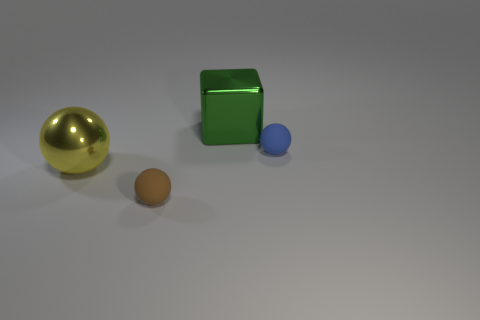Do the yellow shiny object and the brown object have the same shape?
Provide a short and direct response. Yes. How many things are both behind the small brown sphere and on the right side of the yellow shiny ball?
Make the answer very short. 2. Are there the same number of brown matte objects that are to the right of the large cube and brown spheres that are on the left side of the brown thing?
Provide a succinct answer. Yes. Do the shiny ball that is in front of the big green shiny cube and the object behind the blue object have the same size?
Offer a very short reply. Yes. There is a object that is in front of the large green metal block and on the right side of the brown thing; what is its material?
Ensure brevity in your answer.  Rubber. Are there fewer red shiny cylinders than green metal cubes?
Your answer should be compact. Yes. What size is the metal object in front of the metallic thing that is behind the blue ball?
Make the answer very short. Large. What is the shape of the rubber object in front of the ball that is right of the metal object to the right of the yellow metallic ball?
Provide a short and direct response. Sphere. There is a large ball that is made of the same material as the large green thing; what is its color?
Offer a terse response. Yellow. There is a tiny object that is behind the yellow ball that is in front of the metal thing behind the yellow metallic thing; what color is it?
Ensure brevity in your answer.  Blue. 